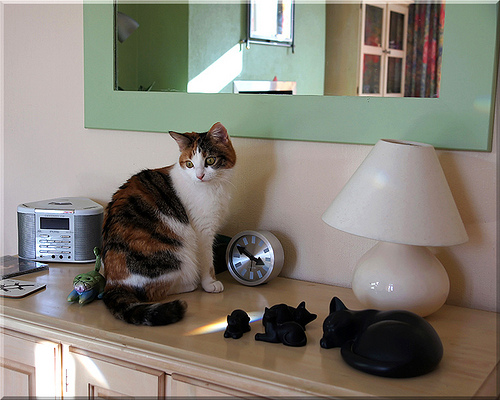<image>
Can you confirm if the cat is in front of the lamp? No. The cat is not in front of the lamp. The spatial positioning shows a different relationship between these objects. 